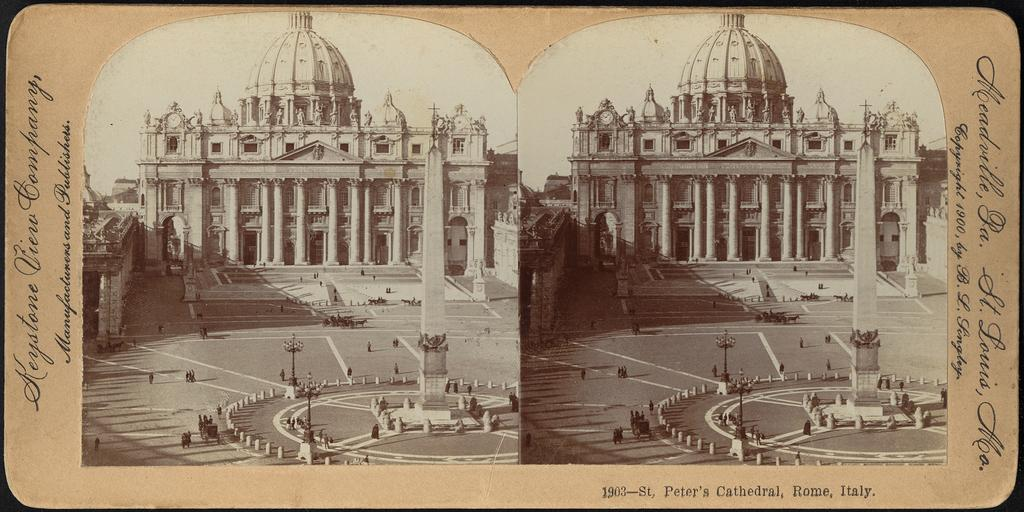Provide a one-sentence caption for the provided image. An old photo with 1903-St. Peter's Cathedral, Rome, Italy written on the bottom right. 